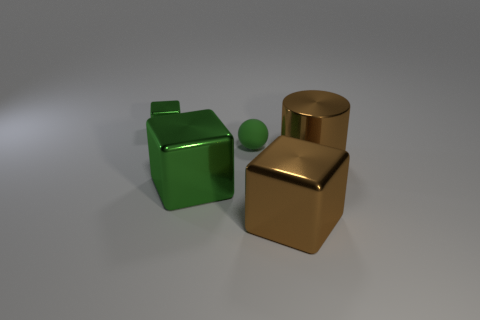Is there any other thing that has the same material as the sphere?
Make the answer very short. No. How many green shiny objects have the same size as the brown metal cube?
Your answer should be compact. 1. Are there the same number of tiny matte things behind the green matte ball and green rubber objects behind the large brown shiny block?
Ensure brevity in your answer.  No. Is the sphere made of the same material as the small green block?
Your answer should be very brief. No. There is a big green shiny object that is in front of the tiny matte thing; is there a large green metal cube that is to the right of it?
Make the answer very short. No. Is there another green object of the same shape as the big green object?
Keep it short and to the point. Yes. Does the matte ball have the same color as the small metallic thing?
Your answer should be very brief. Yes. The small green ball behind the big brown thing left of the brown shiny cylinder is made of what material?
Your answer should be very brief. Rubber. What size is the metallic cylinder?
Offer a terse response. Large. What is the size of the brown cube that is the same material as the large green cube?
Make the answer very short. Large. 